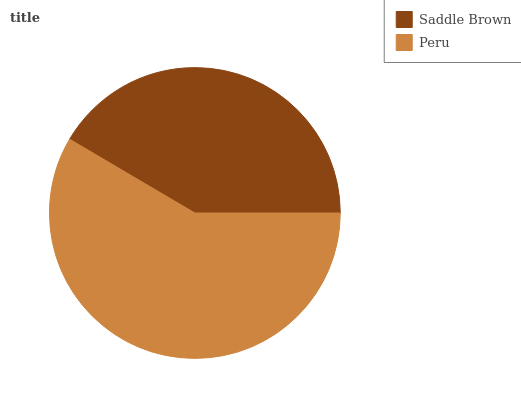Is Saddle Brown the minimum?
Answer yes or no. Yes. Is Peru the maximum?
Answer yes or no. Yes. Is Peru the minimum?
Answer yes or no. No. Is Peru greater than Saddle Brown?
Answer yes or no. Yes. Is Saddle Brown less than Peru?
Answer yes or no. Yes. Is Saddle Brown greater than Peru?
Answer yes or no. No. Is Peru less than Saddle Brown?
Answer yes or no. No. Is Peru the high median?
Answer yes or no. Yes. Is Saddle Brown the low median?
Answer yes or no. Yes. Is Saddle Brown the high median?
Answer yes or no. No. Is Peru the low median?
Answer yes or no. No. 